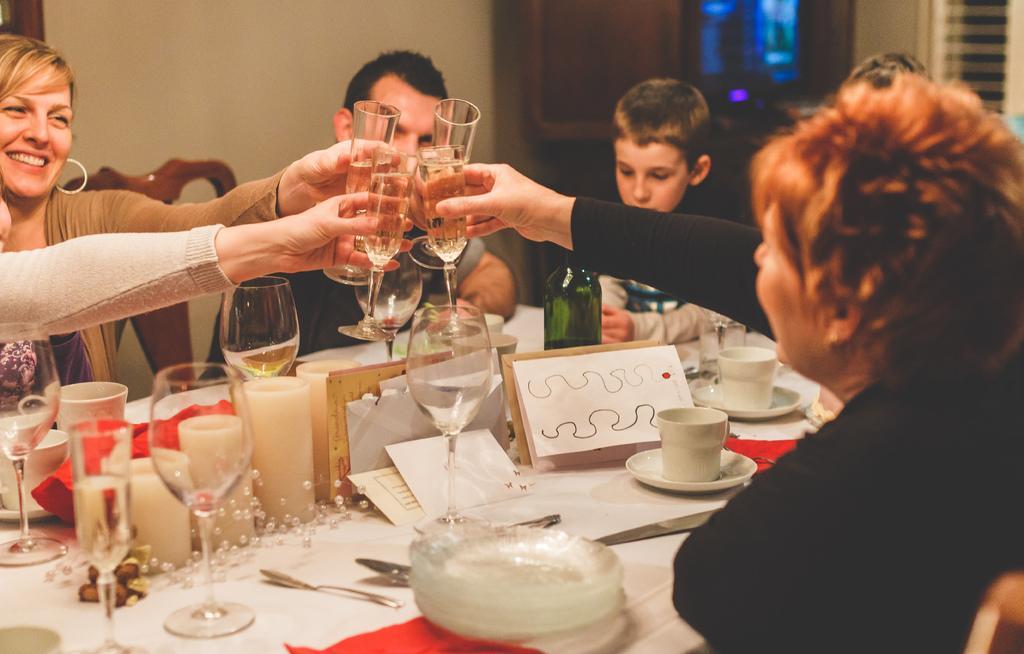Could you give a brief overview of what you see in this image? In the image we can see there are people who are holding wine glasses and taking cheers and on the table there are plates, cup and saucer, knife, spoon, candles. 